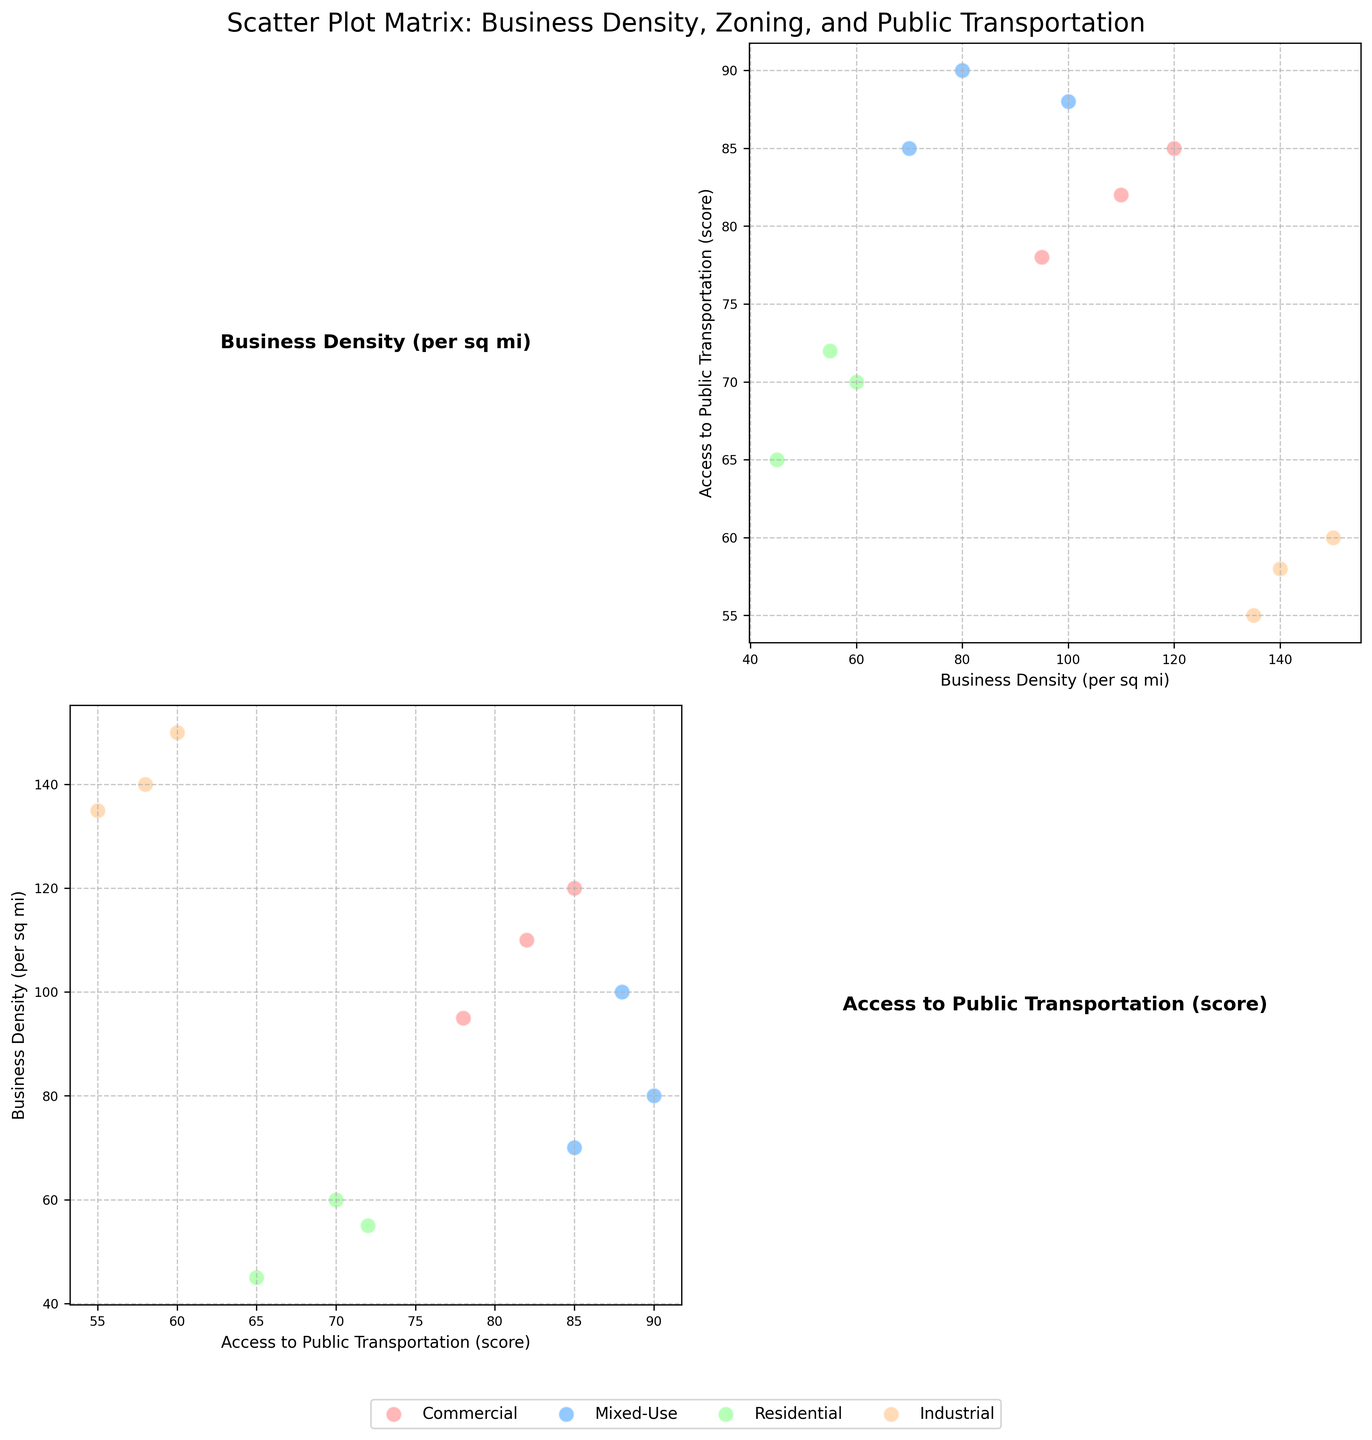What are the titles of the axes labeled in the scatter plot matrix? The scatter plot matrix has two main features, and we can identify them through labels on the axes. All axes are labeled as either 'Business Density (per sq mi)' or 'Access to Public Transportation (score)'.
Answer: 'Business Density (per sq mi)' and 'Access to Public Transportation (score)' How many zoning types are presented in the scatter plot matrix and what are they? The legend in the scatter plot indicates different zoning types represented by varied colors. The four zoning types are Commercial, Mixed-Use, Residential, and Industrial.
Answer: Four: Commercial, Mixed-Use, Residential, Industrial Which zoning type has the highest business density? By examining the scatter plot, we find that the zoning type with the highest business density is Industrial, as seen with data points having values close to or exceeding 135 (Tech Haven, Build Masters, Steel Works).
Answer: Industrial Is there a correlation between business density and access to public transportation for Mixed-Use zones? Observing the diagonal scatter plots for Mixed-Use zones, the dots for this zoning type appear to cluster together around specific values indicating a relationship. It is seen that higher business density correlates moderately with higher access scores.
Answer: Moderate positive correlation Which zoning type has the largest spread in access to public transportation scores? By referring to the scatter plots, Industrial zoning type shows a wide range of access to public transportation scores, ranging from 55 to 60, indicating it has the largest spread when compared to other zones.
Answer: Industrial What is the average business density for Commercial zones? We identify the three Commercial businesses from the plot and sum their business density values (120 + 95 + 110). This gives 325. Dividing by the number of businesses (3) yields the average density.
Answer: 108.33 Compare business density between Residential and Mixed-Use zones. Which is generally higher? By analyzing the scatter plots, Residential business densities range from 45 to 60, while Mixed-Use business densities range from 70 to 100. Therefore, Mixed-Use zones generally have higher business densities.
Answer: Mixed-Use Does any business have both a high business density and a high access to public transportation score? From the scatter plots, we identify that businesses in Industrial zones have high business densities but lower transportation scores. None of the plotted points indicates both high density and high transportation scores.
Answer: No How does the business density of 'Fitness Fusion' compare to 'Cafe Luna'? 'Fitness Fusion' has a business density of 80, while 'Cafe Luna' has a density of 120. Hence, 'Cafe Luna' has a higher business density compared to 'Fitness Fusion'.
Answer: 'Cafe Luna' has a higher business density Do businesses in Residential zones typically have better access to public transportation than those in Industrial zones? Referencing the scatter plots, Residential zones generally show access scores between 65 to 72, while Industrial zones have scores from 55 to 60. Therefore, Residential zones have better access to public transportation on average.
Answer: Yes 